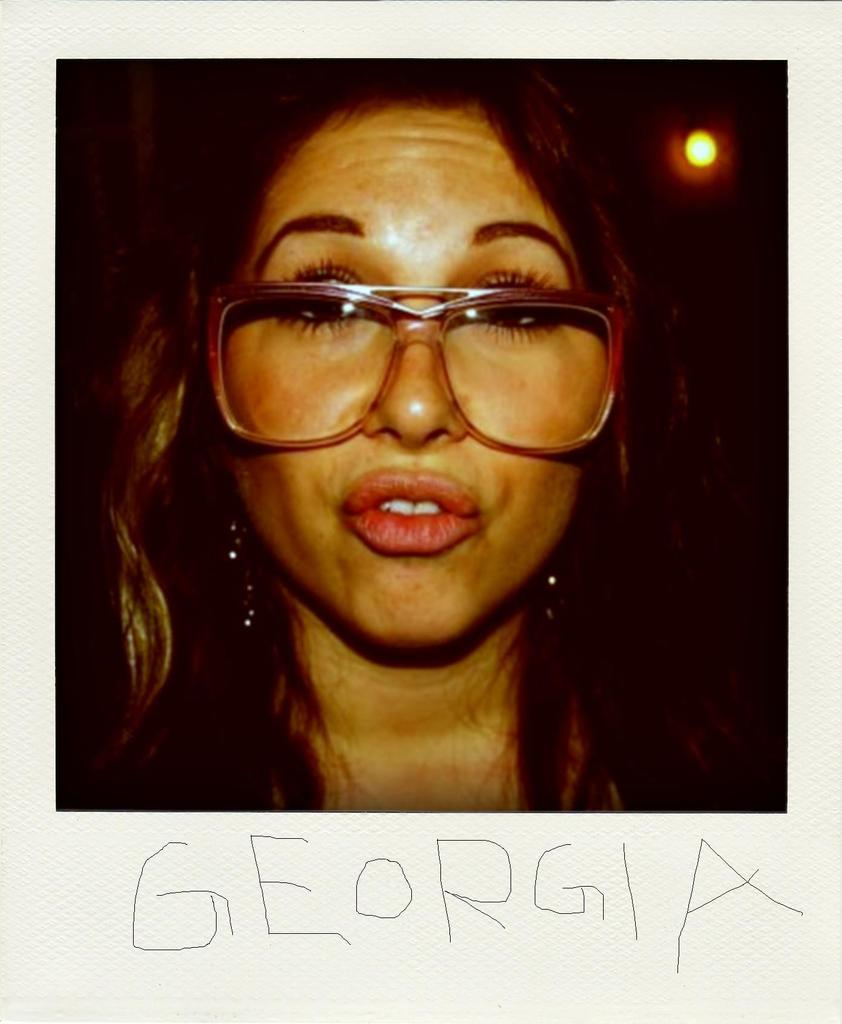Who is present in the image? There is a woman in the image. What accessory is the woman wearing? The woman is wearing glasses. What can be seen in the image that provides illumination? There is a light in the image. What is visible on the image that conveys information or a message? There is something written on the image. How many dolls are sitting on the bread in the image? There are no dolls or bread present in the image. 